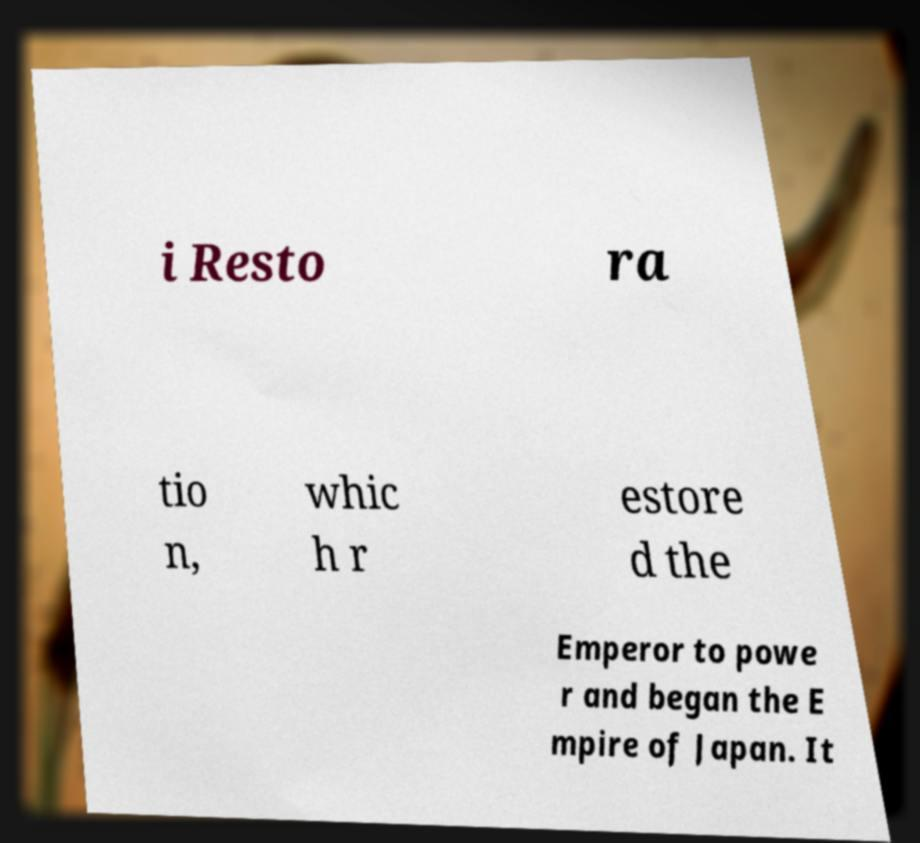What messages or text are displayed in this image? I need them in a readable, typed format. i Resto ra tio n, whic h r estore d the Emperor to powe r and began the E mpire of Japan. It 